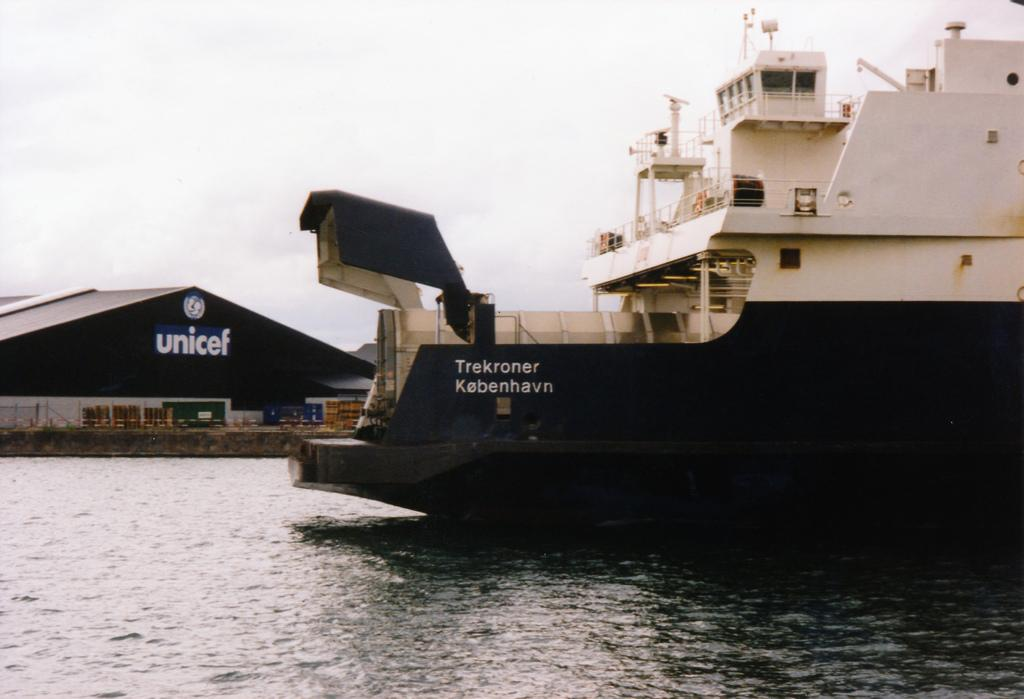Provide a one-sentence caption for the provided image. A boat is on the water in front of a building that has unicef on the sign. 